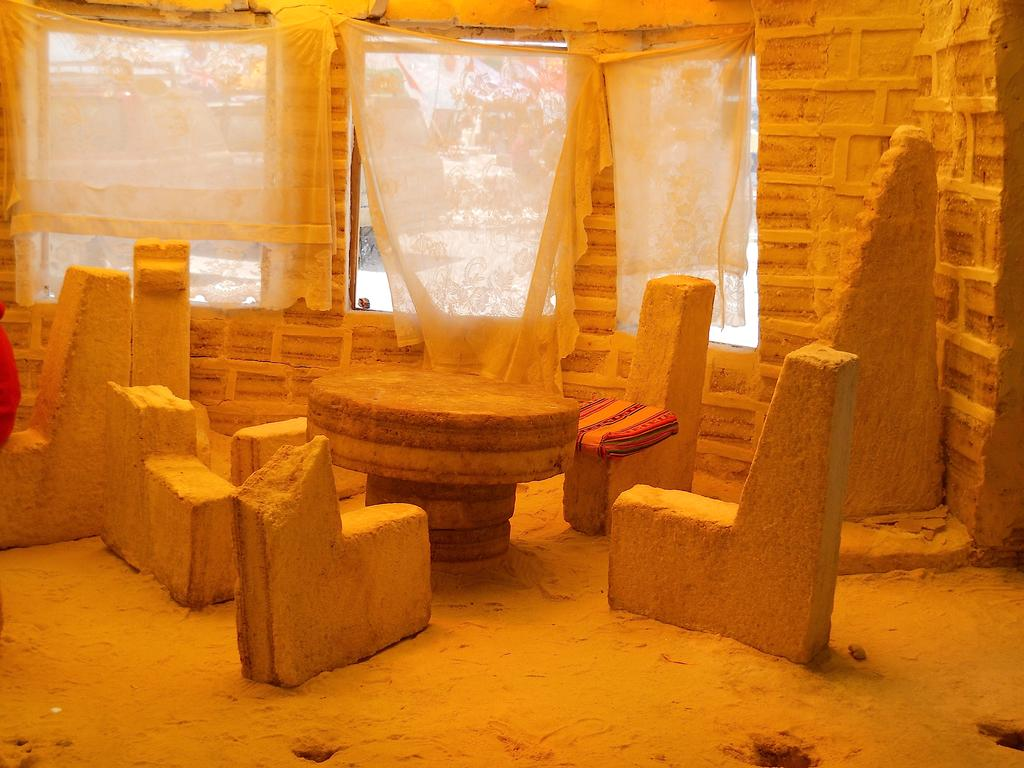What type of furniture is present in the image? There are carved stone chairs in the image. What is the primary piece of furniture in the image? There is a table in the image. What type of window treatment is visible in the image? There are curtains in the image. How many windows are visible in the image? There are windows in the image. What can be seen in the background of the image? There are trees in the background of the image. Are there any bears visible in the image? No, there are no bears present in the image. What finger is pointing at the mailbox in the image? There is no mailbox present in the image. 